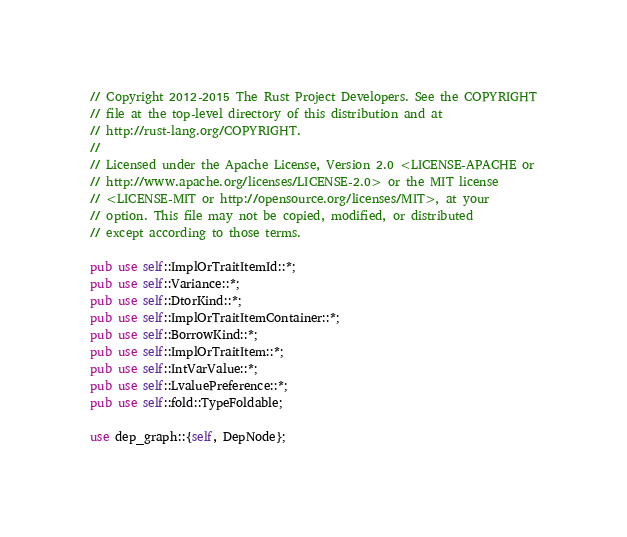Convert code to text. <code><loc_0><loc_0><loc_500><loc_500><_Rust_>// Copyright 2012-2015 The Rust Project Developers. See the COPYRIGHT
// file at the top-level directory of this distribution and at
// http://rust-lang.org/COPYRIGHT.
//
// Licensed under the Apache License, Version 2.0 <LICENSE-APACHE or
// http://www.apache.org/licenses/LICENSE-2.0> or the MIT license
// <LICENSE-MIT or http://opensource.org/licenses/MIT>, at your
// option. This file may not be copied, modified, or distributed
// except according to those terms.

pub use self::ImplOrTraitItemId::*;
pub use self::Variance::*;
pub use self::DtorKind::*;
pub use self::ImplOrTraitItemContainer::*;
pub use self::BorrowKind::*;
pub use self::ImplOrTraitItem::*;
pub use self::IntVarValue::*;
pub use self::LvaluePreference::*;
pub use self::fold::TypeFoldable;

use dep_graph::{self, DepNode};</code> 